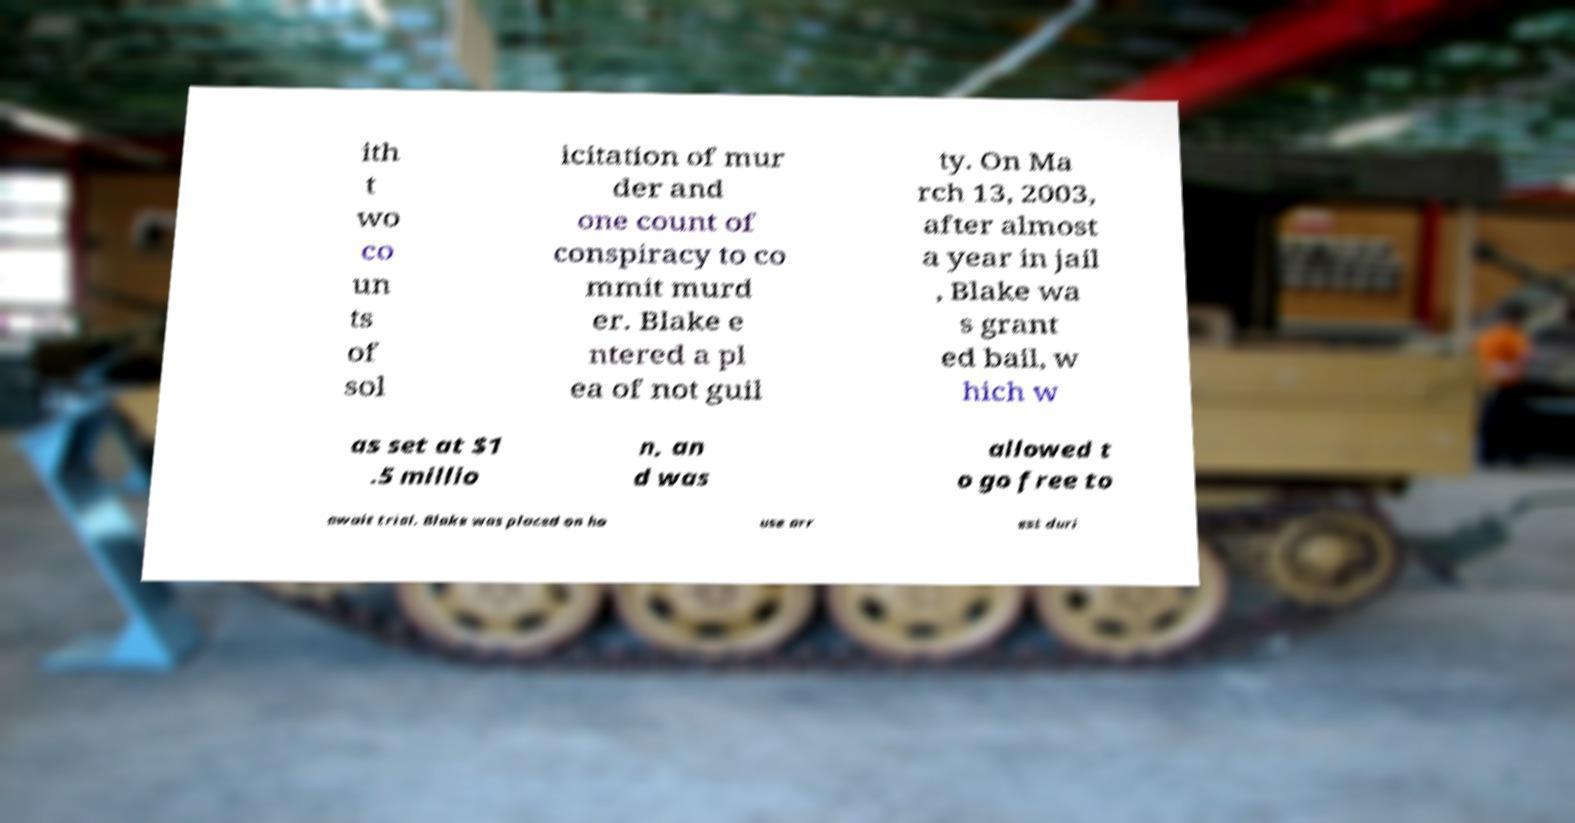There's text embedded in this image that I need extracted. Can you transcribe it verbatim? ith t wo co un ts of sol icitation of mur der and one count of conspiracy to co mmit murd er. Blake e ntered a pl ea of not guil ty. On Ma rch 13, 2003, after almost a year in jail , Blake wa s grant ed bail, w hich w as set at $1 .5 millio n, an d was allowed t o go free to await trial. Blake was placed on ho use arr est duri 